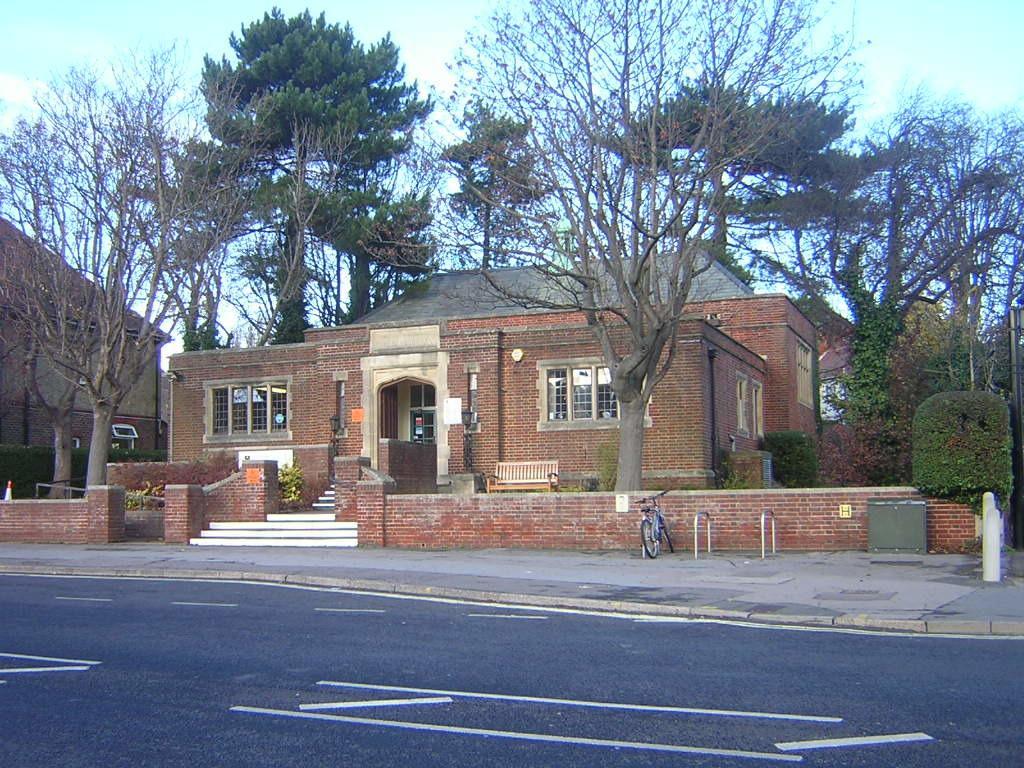Could you give a brief overview of what you see in this image? In the image there is a house, around the house there are many trees and there is a cycle parked in front of the house. 